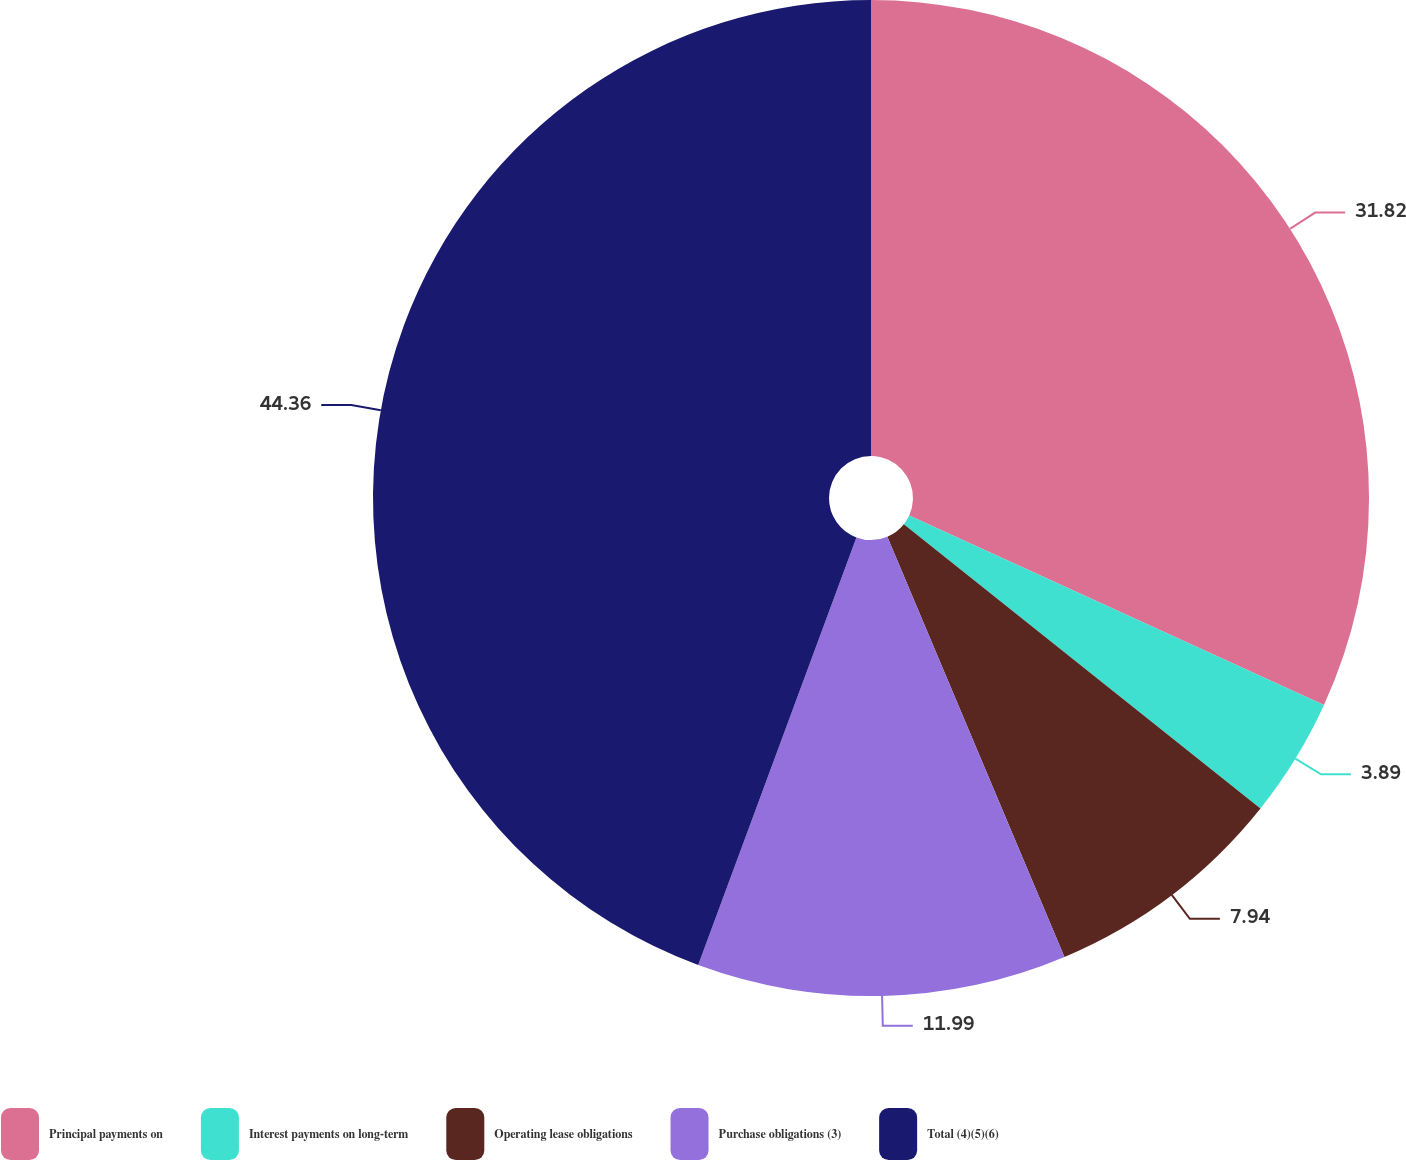<chart> <loc_0><loc_0><loc_500><loc_500><pie_chart><fcel>Principal payments on<fcel>Interest payments on long-term<fcel>Operating lease obligations<fcel>Purchase obligations (3)<fcel>Total (4)(5)(6)<nl><fcel>31.82%<fcel>3.89%<fcel>7.94%<fcel>11.99%<fcel>44.36%<nl></chart> 